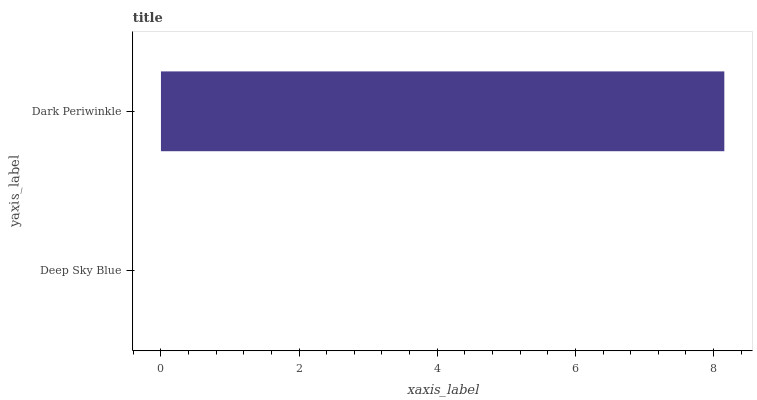Is Deep Sky Blue the minimum?
Answer yes or no. Yes. Is Dark Periwinkle the maximum?
Answer yes or no. Yes. Is Dark Periwinkle the minimum?
Answer yes or no. No. Is Dark Periwinkle greater than Deep Sky Blue?
Answer yes or no. Yes. Is Deep Sky Blue less than Dark Periwinkle?
Answer yes or no. Yes. Is Deep Sky Blue greater than Dark Periwinkle?
Answer yes or no. No. Is Dark Periwinkle less than Deep Sky Blue?
Answer yes or no. No. Is Dark Periwinkle the high median?
Answer yes or no. Yes. Is Deep Sky Blue the low median?
Answer yes or no. Yes. Is Deep Sky Blue the high median?
Answer yes or no. No. Is Dark Periwinkle the low median?
Answer yes or no. No. 